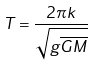Convert formula to latex. <formula><loc_0><loc_0><loc_500><loc_500>T = \frac { 2 \pi k } { \sqrt { g \overline { G M } } }</formula> 